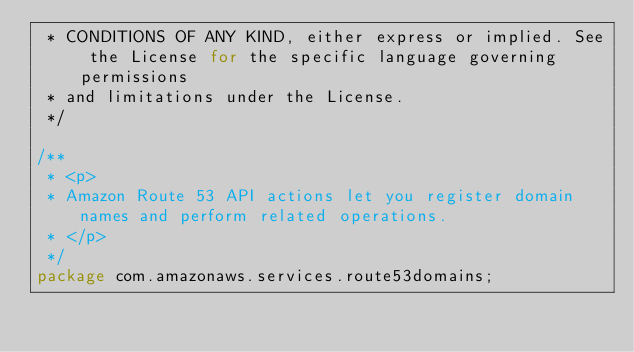<code> <loc_0><loc_0><loc_500><loc_500><_Java_> * CONDITIONS OF ANY KIND, either express or implied. See the License for the specific language governing permissions
 * and limitations under the License.
 */

/**
 * <p>
 * Amazon Route 53 API actions let you register domain names and perform related operations.
 * </p>
 */
package com.amazonaws.services.route53domains;

</code> 